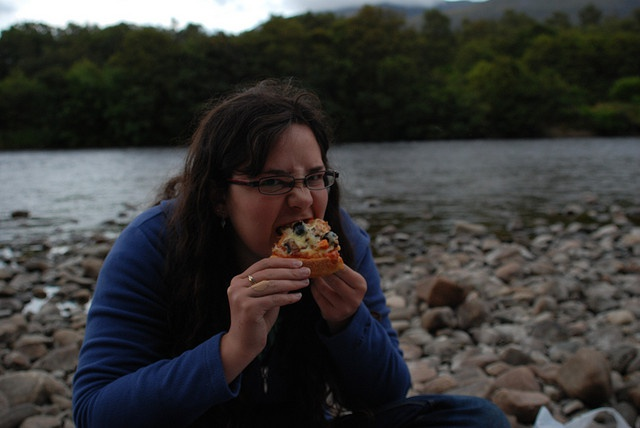Describe the objects in this image and their specific colors. I can see people in lightgray, black, maroon, navy, and brown tones and pizza in lightgray, maroon, gray, and black tones in this image. 